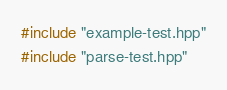Convert code to text. <code><loc_0><loc_0><loc_500><loc_500><_C++_>#include "example-test.hpp"
#include "parse-test.hpp"</code> 